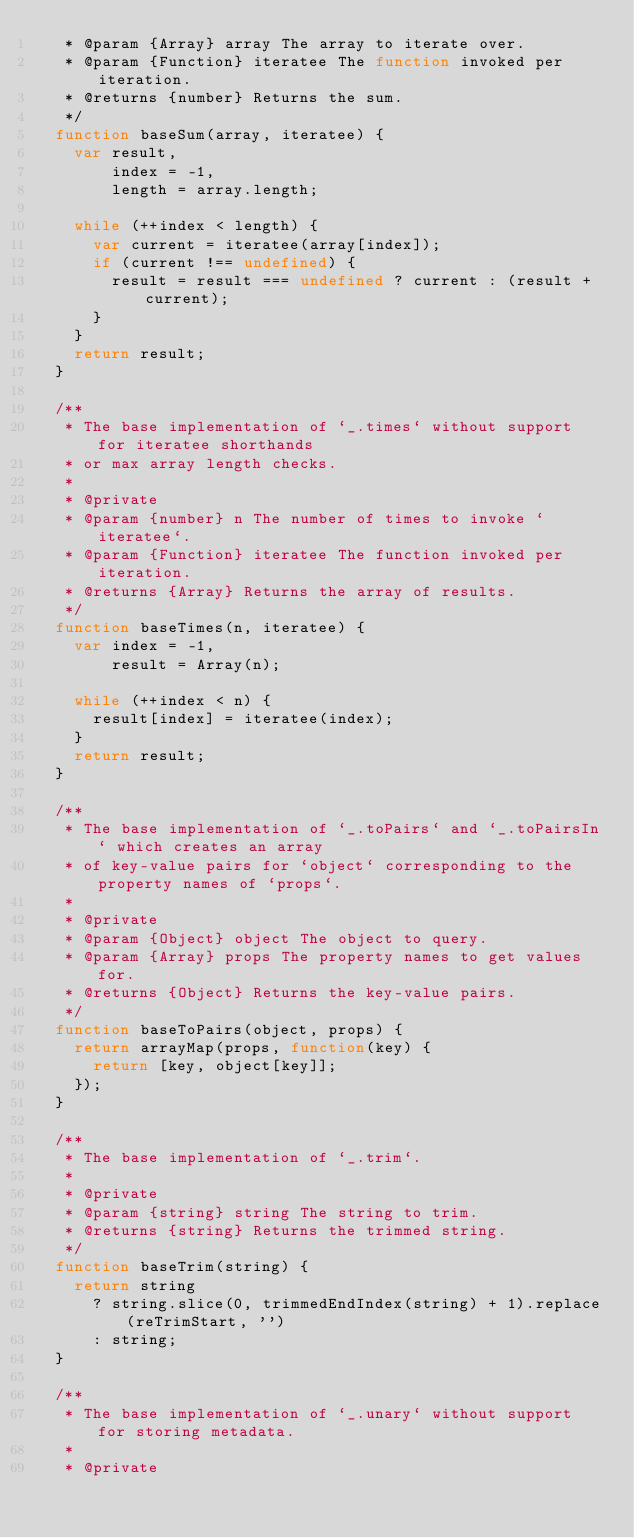<code> <loc_0><loc_0><loc_500><loc_500><_JavaScript_>   * @param {Array} array The array to iterate over.
   * @param {Function} iteratee The function invoked per iteration.
   * @returns {number} Returns the sum.
   */
  function baseSum(array, iteratee) {
    var result,
        index = -1,
        length = array.length;

    while (++index < length) {
      var current = iteratee(array[index]);
      if (current !== undefined) {
        result = result === undefined ? current : (result + current);
      }
    }
    return result;
  }

  /**
   * The base implementation of `_.times` without support for iteratee shorthands
   * or max array length checks.
   *
   * @private
   * @param {number} n The number of times to invoke `iteratee`.
   * @param {Function} iteratee The function invoked per iteration.
   * @returns {Array} Returns the array of results.
   */
  function baseTimes(n, iteratee) {
    var index = -1,
        result = Array(n);

    while (++index < n) {
      result[index] = iteratee(index);
    }
    return result;
  }

  /**
   * The base implementation of `_.toPairs` and `_.toPairsIn` which creates an array
   * of key-value pairs for `object` corresponding to the property names of `props`.
   *
   * @private
   * @param {Object} object The object to query.
   * @param {Array} props The property names to get values for.
   * @returns {Object} Returns the key-value pairs.
   */
  function baseToPairs(object, props) {
    return arrayMap(props, function(key) {
      return [key, object[key]];
    });
  }

  /**
   * The base implementation of `_.trim`.
   *
   * @private
   * @param {string} string The string to trim.
   * @returns {string} Returns the trimmed string.
   */
  function baseTrim(string) {
    return string
      ? string.slice(0, trimmedEndIndex(string) + 1).replace(reTrimStart, '')
      : string;
  }

  /**
   * The base implementation of `_.unary` without support for storing metadata.
   *
   * @private</code> 